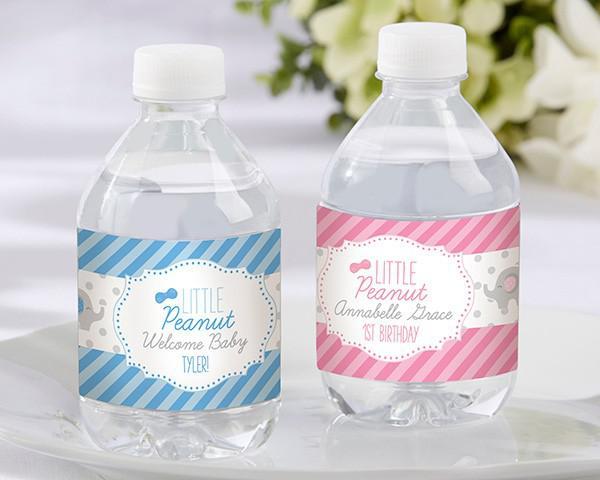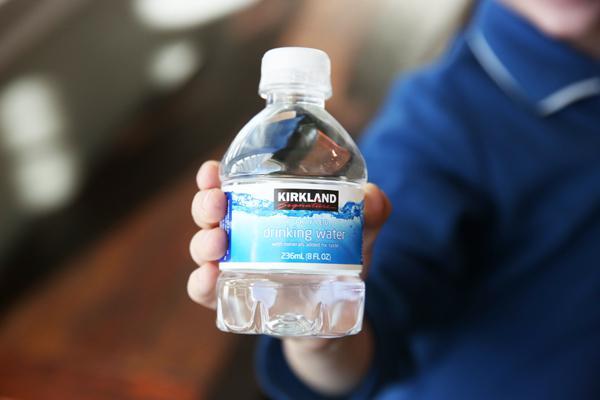The first image is the image on the left, the second image is the image on the right. For the images displayed, is the sentence "There are no more than six water bottles in total." factually correct? Answer yes or no. Yes. The first image is the image on the left, the second image is the image on the right. Assess this claim about the two images: "In at least one image there are two water bottles with a label that reference a new baby.". Correct or not? Answer yes or no. Yes. 